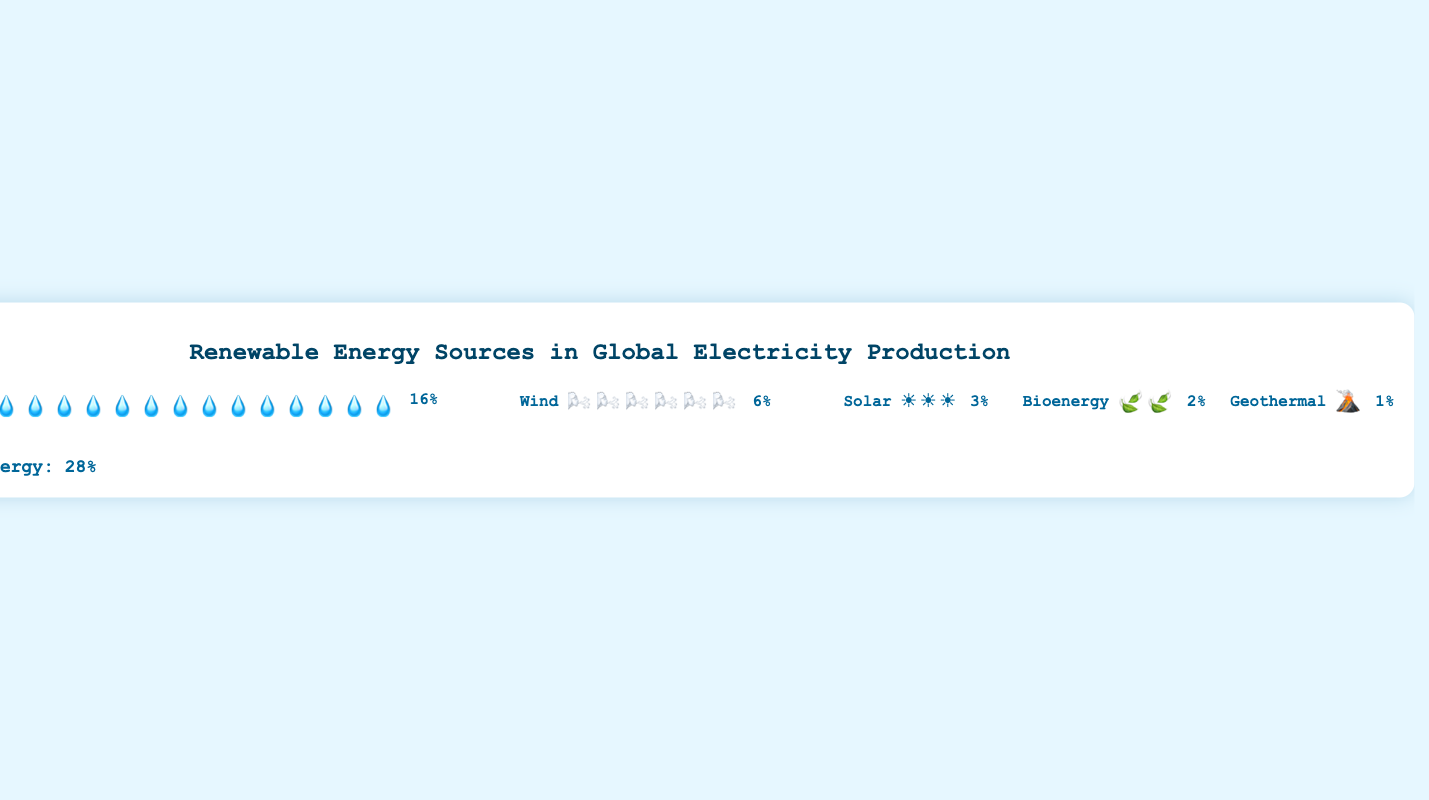what is the total percentage of renewable energy in global electricity production? The total percentage is shown at the bottom of the chart labeled "Total Renewable Energy: 28%".
Answer: 28% Which source contributes the highest percentage to renewable energy? By looking at the chart, Hydropower has the most icons (16 water droplets) compared to other sources, indicating it contributes the highest percentage at 16%.
Answer: Hydropower How many more percentage points does Wind contribute compared to Geothermal? Wind contributes 6%, and Geothermal contributes 1%. The difference can be found by subtracting 1% from 6%.
Answer: 5% What is the percentage contribution of Solar energy? Solar energy's contribution is labeled as 3% in the chart.
Answer: 3% Which renewable source contributes the least in global electricity production? Geothermal has only one icon representing a 1% contribution, the smallest compared to other sources.
Answer: Geothermal How many icons represent the Bioenergy contribution? Bioenergy is represented by icons of leaves, and there are 2 leaf icons.
Answer: 2 Combine the contributions of Solar and Bioenergy. What is their combined percentage? Solar contributes 3% and Bioenergy 2%, adding them together gives 3% + 2% = 5%.
Answer: 5% Is the percentage of contribution from Wind more than that from Solar and Bioenergy combined? Wind contributes 6%, while Solar and Bioenergy combined contribute 3% + 2% = 5%. Comparing 6% and 5%, Wind's contribution is higher.
Answer: Yes By how many percentage points does Hydropower's contribution exceed that of Wind? Hydropower contributes 16%, while Wind contributes 6%. The difference is 16% - 6%.
Answer: 10% What is the ratio of the total percentage of Hydropower to Bioenergy? Hydropower contributes 16%, and Bioenergy contributes 2%. The ratio is 16 divided by 2.
Answer: 8:1 